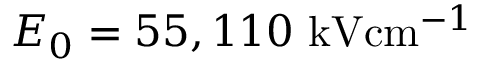<formula> <loc_0><loc_0><loc_500><loc_500>E _ { 0 } = 5 5 , 1 1 0 { k V c m ^ { - 1 } }</formula> 